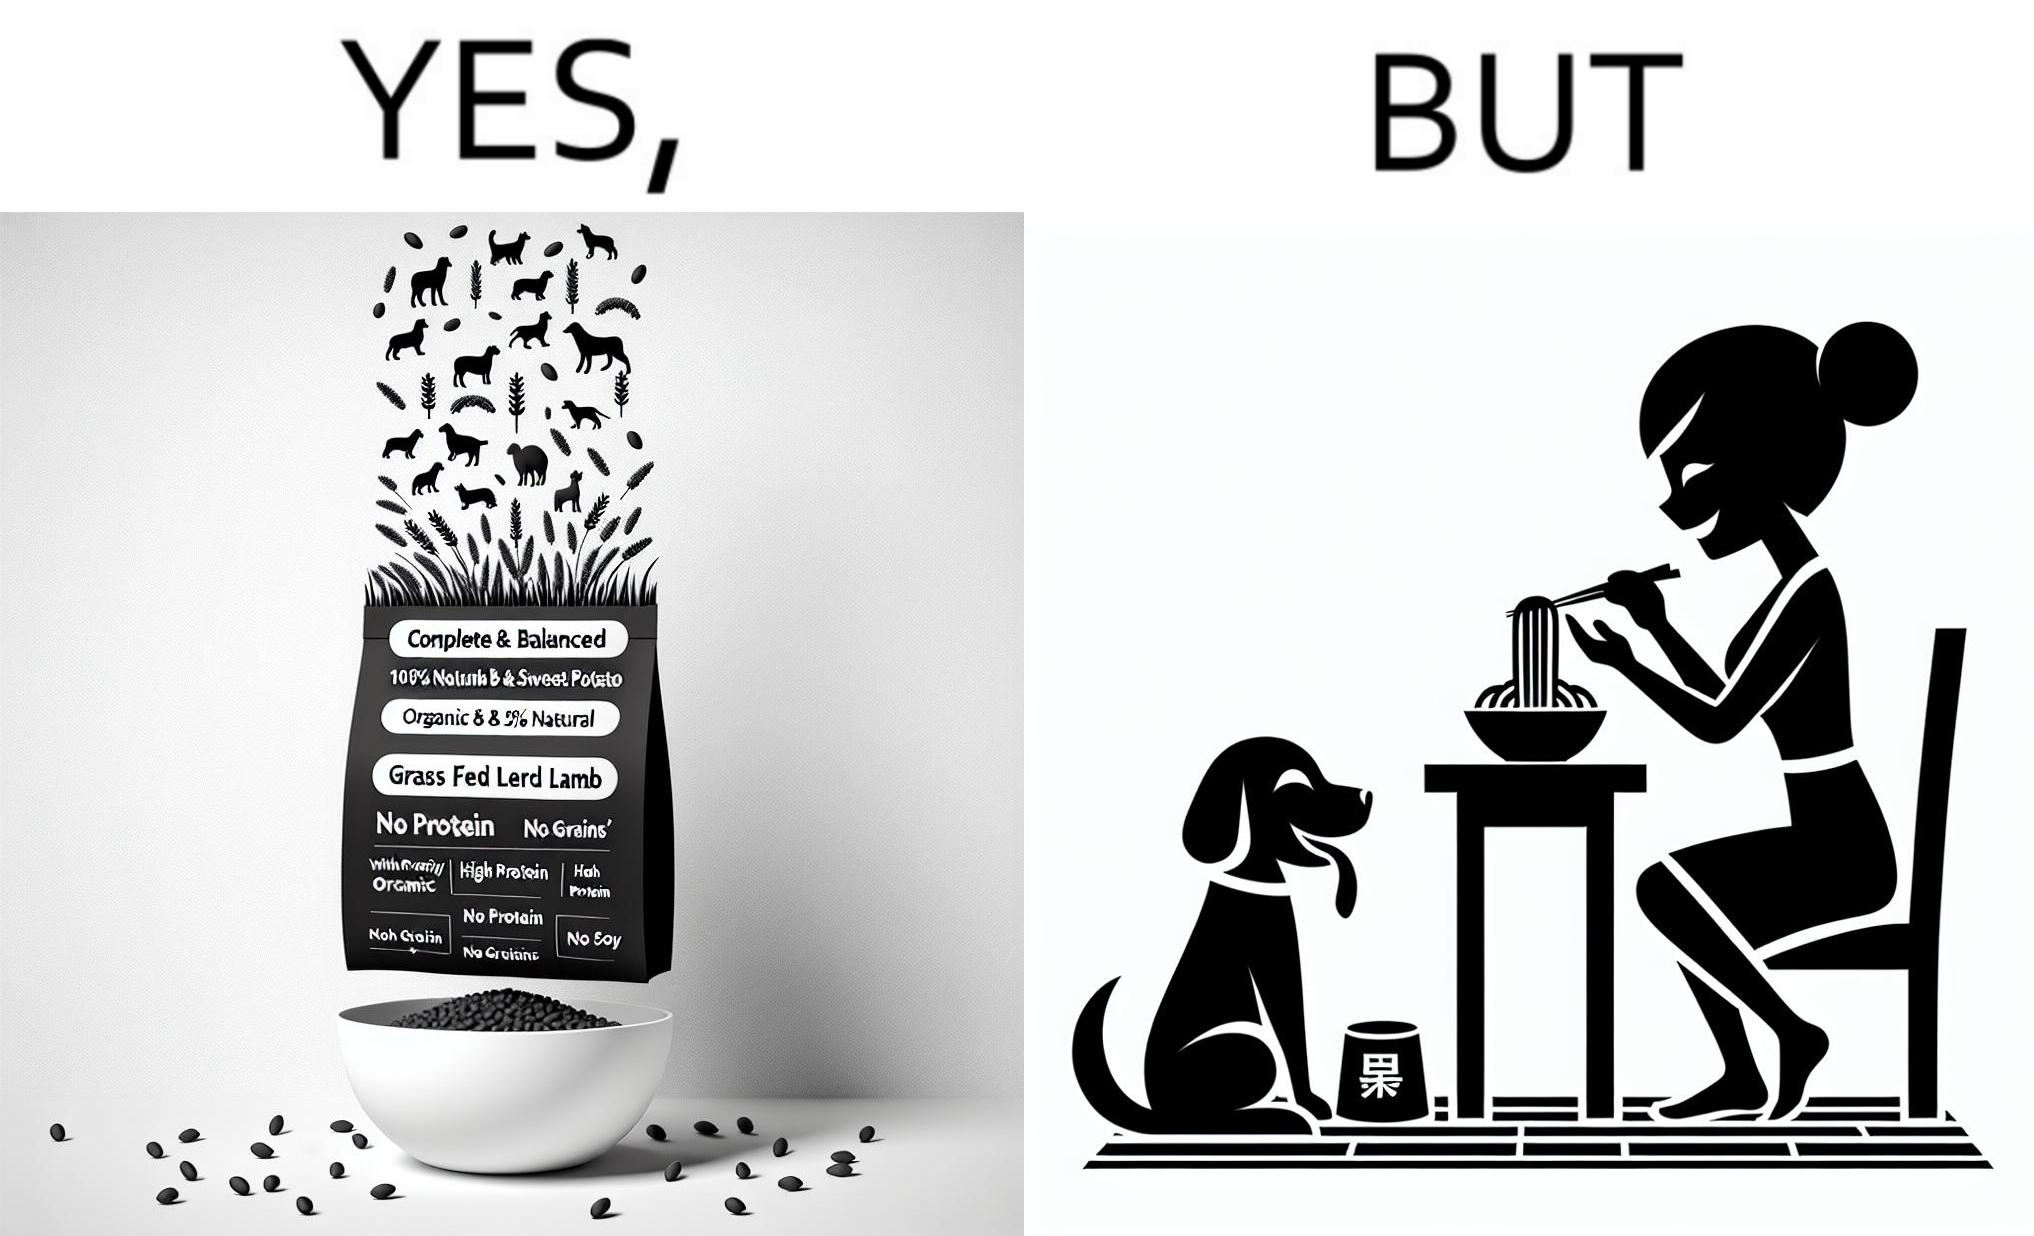Explain the humor or irony in this image. The image is funny because while the food for the dog that the woman pours is well balanced, the food that she herself is eating is bad for her health. 